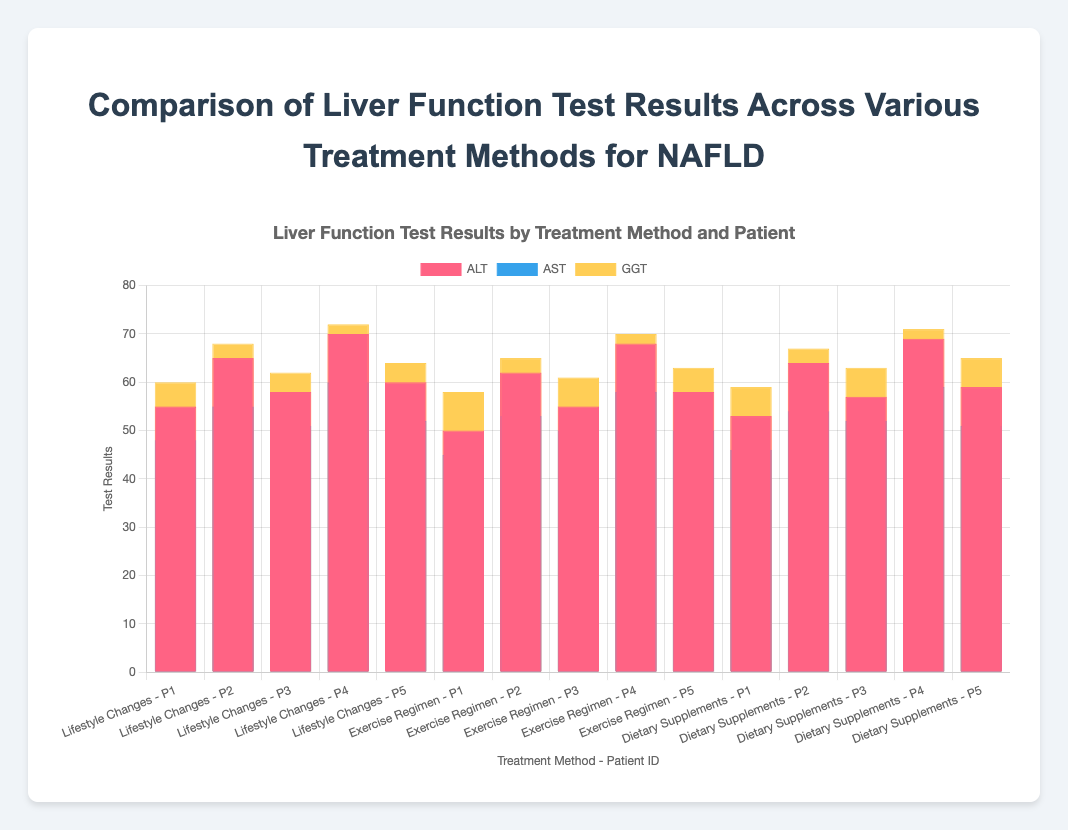How do the ALT levels for Patient P1 compare across the three treatment methods? Look at the bar heights for ALT corresponding to Lifestyle Changes, Exercise Regimen, and Dietary Supplements for Patient P1. For Lifestyle Changes, ALT is 55; for Exercise Regimen, it is 50; and for Dietary Supplements, it is 53.
Answer: Lifestyle Changes: 55, Exercise Regimen: 50, Dietary Supplements: 53 Which patient had the highest GGT level, and under which treatment method? Check the heights of the GGT bars for each patient across all treatment methods. The highest GGT level is 72 for Patient P4 under the Lifestyle Changes treatment method.
Answer: P4 with Lifestyle Changes What is the average AST level across all patients under the Exercise Regimen? Identify the AST levels for patients P1, P2, P3, P4, and P5 under the Exercise Regimen. They are 45, 53, 50, 58, and 50 respectively. Sum them up (45 + 53 + 50 + 58 + 50 = 256) and divide by the number of patients (5).
Answer: 51.2 Which treatment method resulted in the lowest Total Bilirubin levels for Patient P3? Compare the bar heights for Total Bilirubin for Patient P3 across Lifestyle Changes, Exercise Regimen, and Dietary Supplements. They are 1.3, 1.1, and 1.2 respectively. The lowest is under Exercise Regimen at 1.1.
Answer: Exercise Regimen How do the AST levels under Dietary Supplements compare between Patient P2 and Patient P4? Look at the bar heights for AST under Dietary Supplements for Patient P2 and Patient P4. For Patient P2, AST is 54; for Patient P4, it is 59. Patient P4 has the higher AST level at 59.
Answer: P4 has higher AST (59) What is the total GGT level for Patient P5 across all treatment methods? Sum the GGT levels for Patient P5 under Lifestyle Changes, Exercise Regimen, and Dietary Supplements. They are 64, 63, and 65 respectively. Summing these values: 64 + 63 + 65 = 192.
Answer: 192 Which liver function test had the highest average values across all patients and treatment methods: ALT, AST, or GGT? Calculate the average value for each test across all data points. Sum all values of ALT, AST, and GGT separately, and divide by the number of data points (15 each):
- Total ALT: 55 + 50 + 53 + 65 + 62 + 64 + 58 + 55 + 57 + 70 + 68 + 69 + 60 + 58 + 59 = 903, average = 903 / 15 = 60.2
- Total AST: 48 + 45 + 46 + 55 + 53 + 54 + 51 + 50 + 52 + 60 + 58 + 59 + 52 + 50 + 51 = 734, average = 734 / 15 = 48.9
- Total GGT: 60 + 58 + 59 + 68 + 65 + 67 + 62 + 61 + 63 + 72 + 70 + 71 + 64 + 63 + 65 = 968, average = 968 / 15 = 64.53
The highest average value is for GGT: 64.53.
Answer: GGT Which treatment method appears to have the most consistent (smallest range) AST levels across all patients? Calculate the range (max minus min) of AST levels for each treatment method across all patients:
- Lifestyle Changes: [48, 55, 51, 60, 52], range = 60 - 48 = 12
- Exercise Regimen: [45, 53, 50, 58, 50], range = 58 - 45 = 13
- Dietary Supplements: [46, 54, 52, 59, 51], range = 59 - 46 = 13
The smallest range is for Lifestyle Changes at 12.
Answer: Lifestyle Changes 